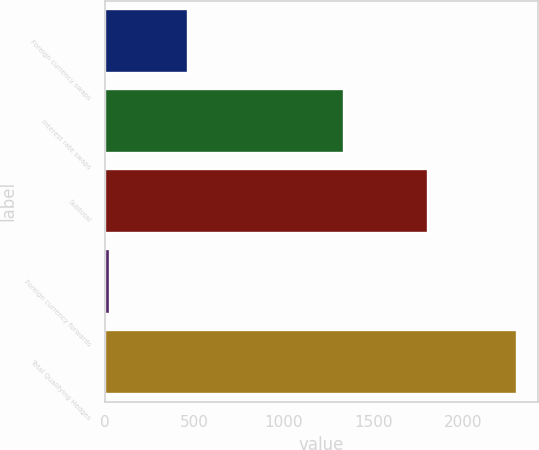<chart> <loc_0><loc_0><loc_500><loc_500><bar_chart><fcel>Foreign currency swaps<fcel>Interest rate swaps<fcel>Subtotal<fcel>Foreign currency forwards<fcel>Total Qualifying Hedges<nl><fcel>467<fcel>1338<fcel>1805<fcel>32<fcel>2301<nl></chart> 